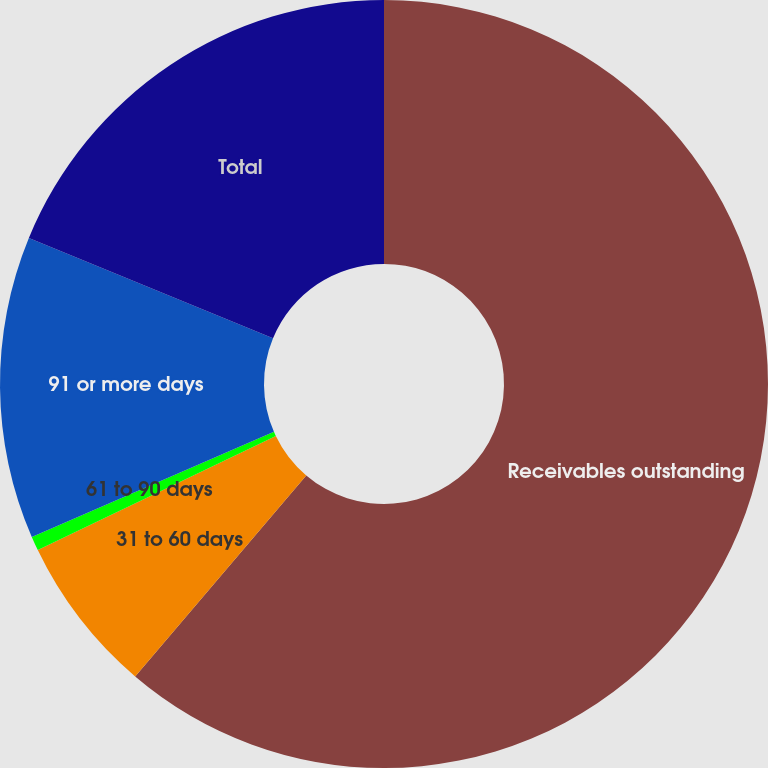Convert chart. <chart><loc_0><loc_0><loc_500><loc_500><pie_chart><fcel>Receivables outstanding<fcel>31 to 60 days<fcel>61 to 90 days<fcel>91 or more days<fcel>Total<nl><fcel>61.22%<fcel>6.66%<fcel>0.6%<fcel>12.73%<fcel>18.79%<nl></chart> 